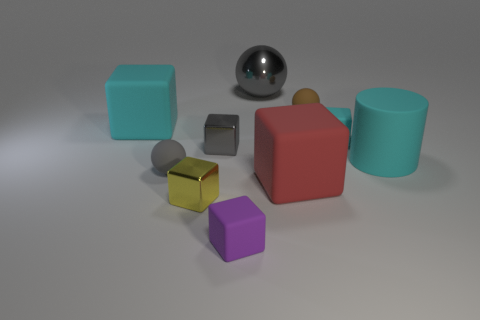Subtract all gray cubes. How many cubes are left? 5 Subtract all red balls. How many cyan blocks are left? 2 Subtract all yellow cubes. How many cubes are left? 5 Subtract all cubes. How many objects are left? 4 Subtract all yellow blocks. Subtract all green spheres. How many blocks are left? 5 Add 9 tiny yellow metal blocks. How many tiny yellow metal blocks are left? 10 Add 4 yellow metallic cylinders. How many yellow metallic cylinders exist? 4 Subtract 1 red blocks. How many objects are left? 9 Subtract all tiny purple rubber cylinders. Subtract all purple matte objects. How many objects are left? 9 